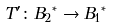<formula> <loc_0><loc_0><loc_500><loc_500>T ^ { \prime } \colon { B _ { 2 } } ^ { * } \rightarrow { B _ { 1 } } ^ { * }</formula> 